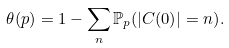<formula> <loc_0><loc_0><loc_500><loc_500>\theta ( p ) = 1 - \sum _ { n } { \mathbb { P } _ { p } ( | C ( 0 ) | = n ) } .</formula> 